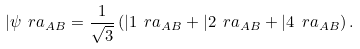<formula> <loc_0><loc_0><loc_500><loc_500>| \psi \ r a _ { A B } = \frac { 1 } { \sqrt { 3 } } \left ( | 1 \ r a _ { A B } + | 2 \ r a _ { A B } + | 4 \ r a _ { A B } \right ) .</formula> 